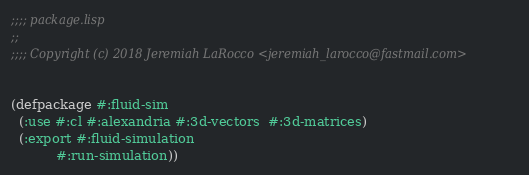Convert code to text. <code><loc_0><loc_0><loc_500><loc_500><_Lisp_>;;;; package.lisp
;;
;;;; Copyright (c) 2018 Jeremiah LaRocco <jeremiah_larocco@fastmail.com>


(defpackage #:fluid-sim
  (:use #:cl #:alexandria #:3d-vectors  #:3d-matrices)
  (:export #:fluid-simulation
           #:run-simulation))
</code> 